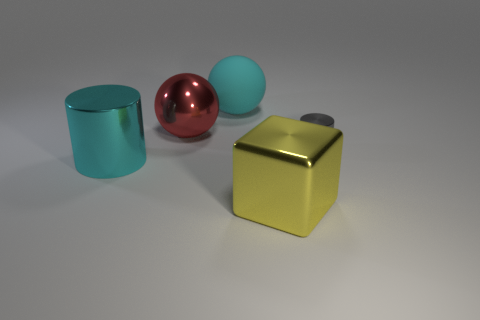There is a shiny cylinder that is right of the cyan object behind the metallic cylinder left of the big yellow cube; what color is it?
Your response must be concise. Gray. Is there a yellow shiny thing that is behind the large cyan thing in front of the cyan matte object?
Provide a short and direct response. No. There is a shiny thing in front of the cyan metallic object; does it have the same color as the shiny cylinder right of the cyan matte ball?
Give a very brief answer. No. How many cyan metal objects are the same size as the block?
Your answer should be very brief. 1. Does the shiny cylinder that is behind the cyan metal cylinder have the same size as the block?
Your answer should be very brief. No. The gray metal thing has what shape?
Provide a succinct answer. Cylinder. There is a object that is the same color as the large shiny cylinder; what is its size?
Offer a terse response. Large. Is the object that is behind the big red thing made of the same material as the big cyan cylinder?
Make the answer very short. No. Is there a large rubber thing that has the same color as the metallic ball?
Ensure brevity in your answer.  No. Do the big cyan thing behind the gray cylinder and the large cyan thing in front of the gray shiny object have the same shape?
Provide a succinct answer. No. 